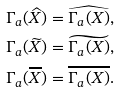<formula> <loc_0><loc_0><loc_500><loc_500>\Gamma _ { a } ( \widehat { X } ) & = \widehat { \Gamma _ { a } ( X ) } , \\ \Gamma _ { a } ( \widetilde { X } ) & = \widetilde { \Gamma _ { a } ( X ) } , \\ \Gamma _ { a } ( \overline { X } ) & = \overline { \Gamma _ { a } ( X ) } .</formula> 